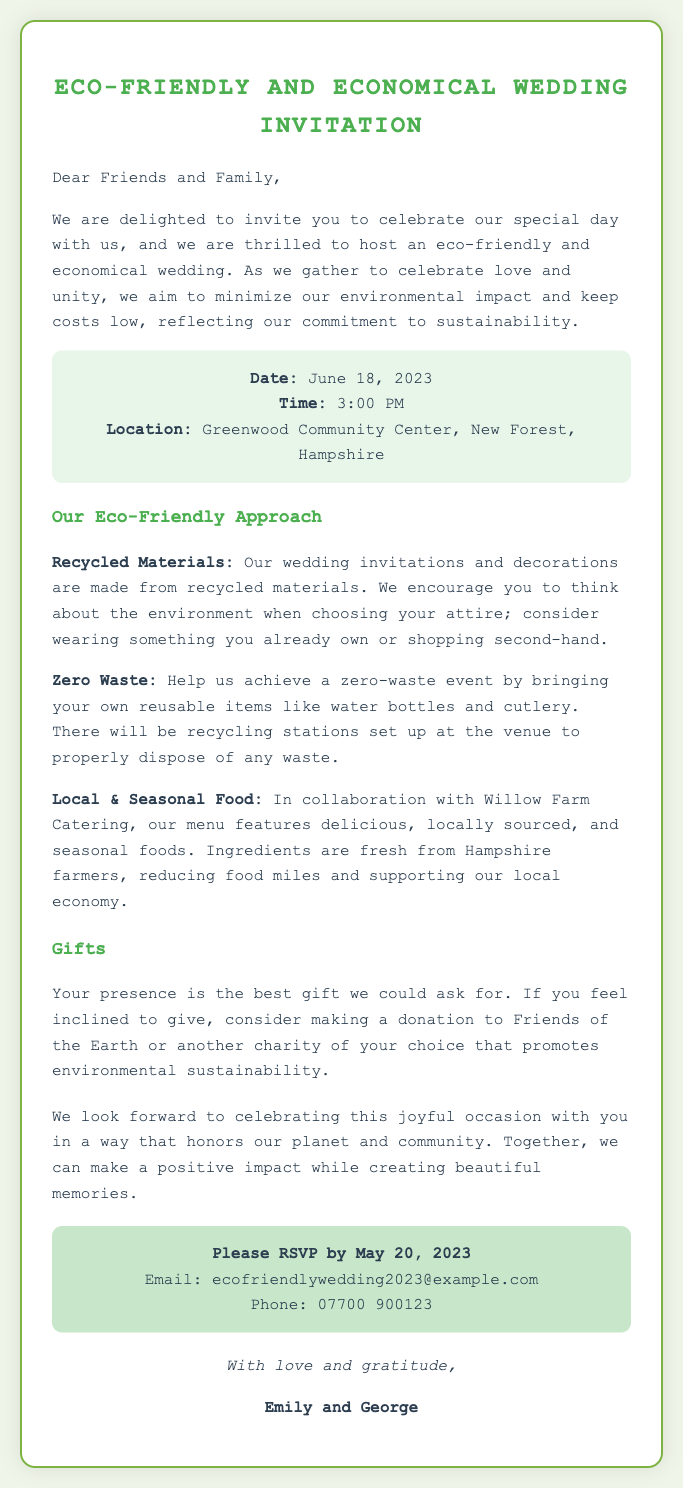what is the date of the wedding? The date of the wedding is explicitly stated in the document as June 18, 2023.
Answer: June 18, 2023 what is the location of the wedding? The document specifies the wedding location as the Greenwood Community Center, New Forest, Hampshire.
Answer: Greenwood Community Center, New Forest, Hampshire what time does the wedding start? The starting time is mentioned clearly in the invitation as 3:00 PM.
Answer: 3:00 PM what type of food will be served at the wedding? The invitation highlights that the menu features locally sourced and seasonal foods.
Answer: locally sourced and seasonal foods why is the couple requesting guests to consider wearing second-hand attire? This request is made as part of their eco-friendly approach, encouraging sustainability in their wedding celebrations.
Answer: sustainability what should guests bring to support a zero-waste event? The document advises guests to bring reusable items like water bottles and cutlery.
Answer: reusable items who is the couple’s preferred charity for donations? The invitation suggests making donations to Friends of the Earth or another charity promoting environmental sustainability.
Answer: Friends of the Earth when is the RSVP deadline? The RSVP deadline is mentioned as May 20, 2023.
Answer: May 20, 2023 what is the couple’s names? The names of the couple are stated at the end of the invitation as Emily and George.
Answer: Emily and George 